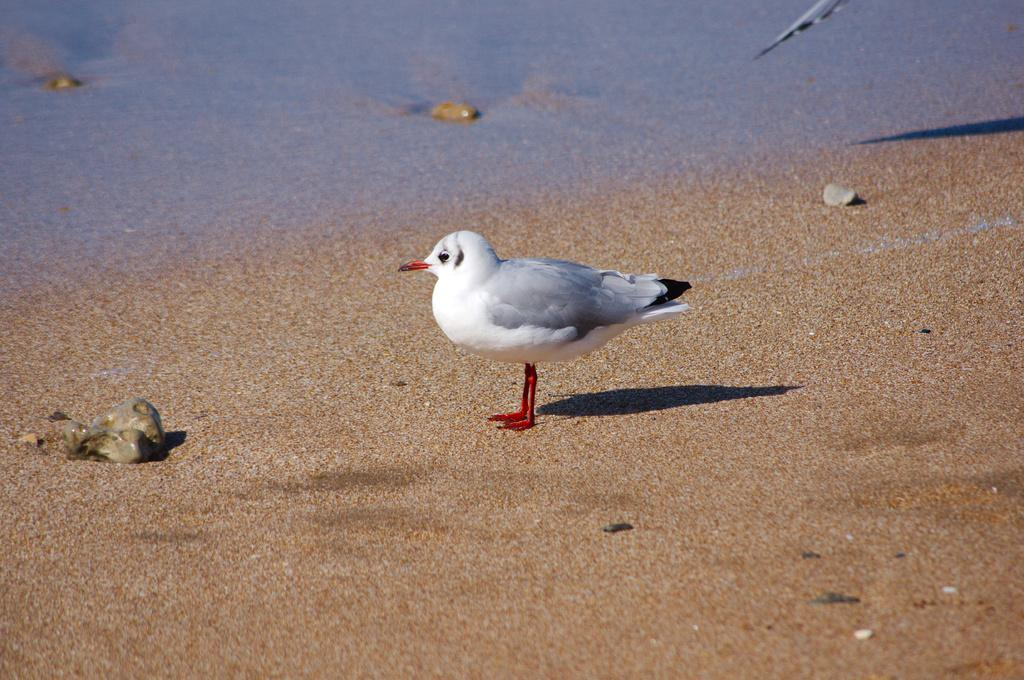What type of animal is in the image? There is a bird in the image. Can you describe the bird's coloring? The bird has white, gray, and black coloring. What type of terrain is visible in the image? There is sand and stones visible in the image. What else can be seen in the image besides the bird and terrain? There is water visible in the image. What type of noise can be heard coming from the cows in the image? There are no cows present in the image, so it's not possible to determine what noise they might be making. 